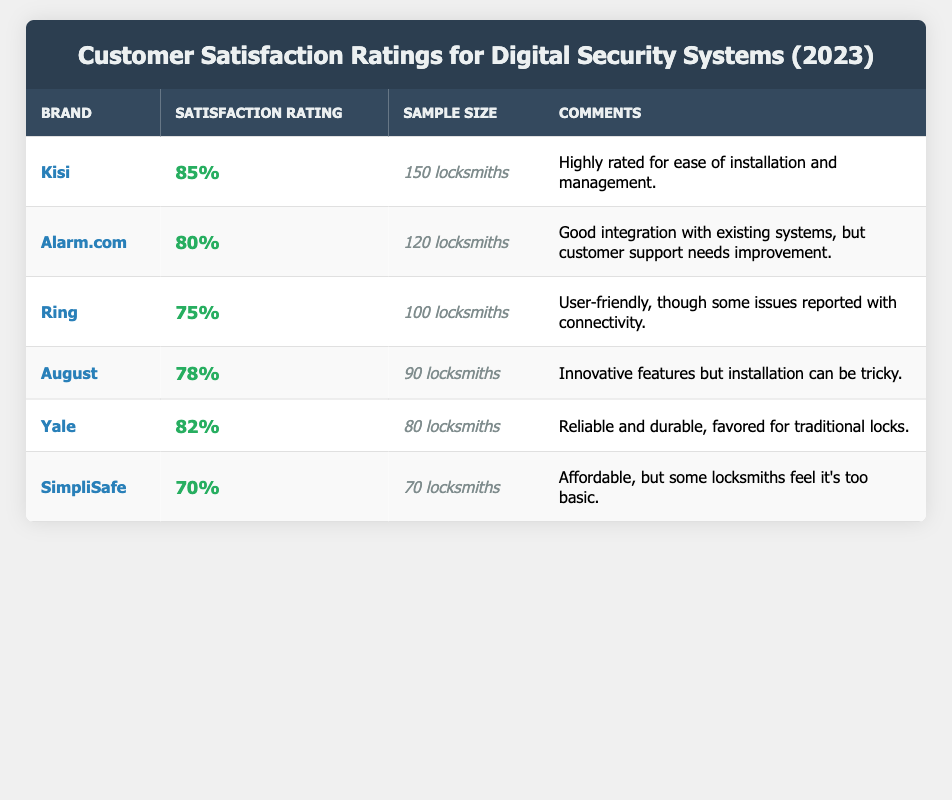What is the satisfaction rating for Kisi? The satisfaction rating for Kisi is directly listed in the table under the "Satisfaction Rating" column for that brand, which shows 85%.
Answer: 85% How many locksmiths were sampled for Alarm.com? The number of locksmiths sampled for Alarm.com can be found in the table, specifically in the "Sample Size" column next to that brand, which indicates 120 locksmiths.
Answer: 120 locksmiths What is the difference in satisfaction ratings between Ring and August? The satisfaction rating for Ring is 75%, and for August it is 78%. To find the difference, subtract 75 from 78, resulting in a difference of 3%.
Answer: 3% Which brand has the lowest satisfaction rating? By scanning the "Satisfaction Rating" column, SimpliSafe has the lowest rating at 70%.
Answer: SimpliSafe What is the average satisfaction rating of the brands listed? To calculate the average, sum all satisfaction ratings: 85 + 80 + 75 + 78 + 82 + 70 = 470. Then divide by the number of brands (6), which gives an average of 78.33%.
Answer: 78.33% Is it true that Yale has a higher satisfaction rating than Alarm.com? Yale's satisfaction rating is 82%, while Alarm.com's is 80%. Therefore, it is true that Yale has a higher rating.
Answer: Yes What percentage of sampled locksmiths rated Kisi? Kisi has a sample size of 150 locksmiths, which is noted in the "Sample Size" column of the table.
Answer: 150 locksmiths Which brand received comments regarding customer support improvement? The comments for Alarm.com mention that customer support needs improvement, which can be found in the "Comments" column for that brand.
Answer: Alarm.com What brands have satisfaction ratings above 80%? Looking through the table, Kisi (85%) and Yale (82%) are the only brands with ratings above 80%.
Answer: Kisi and Yale 